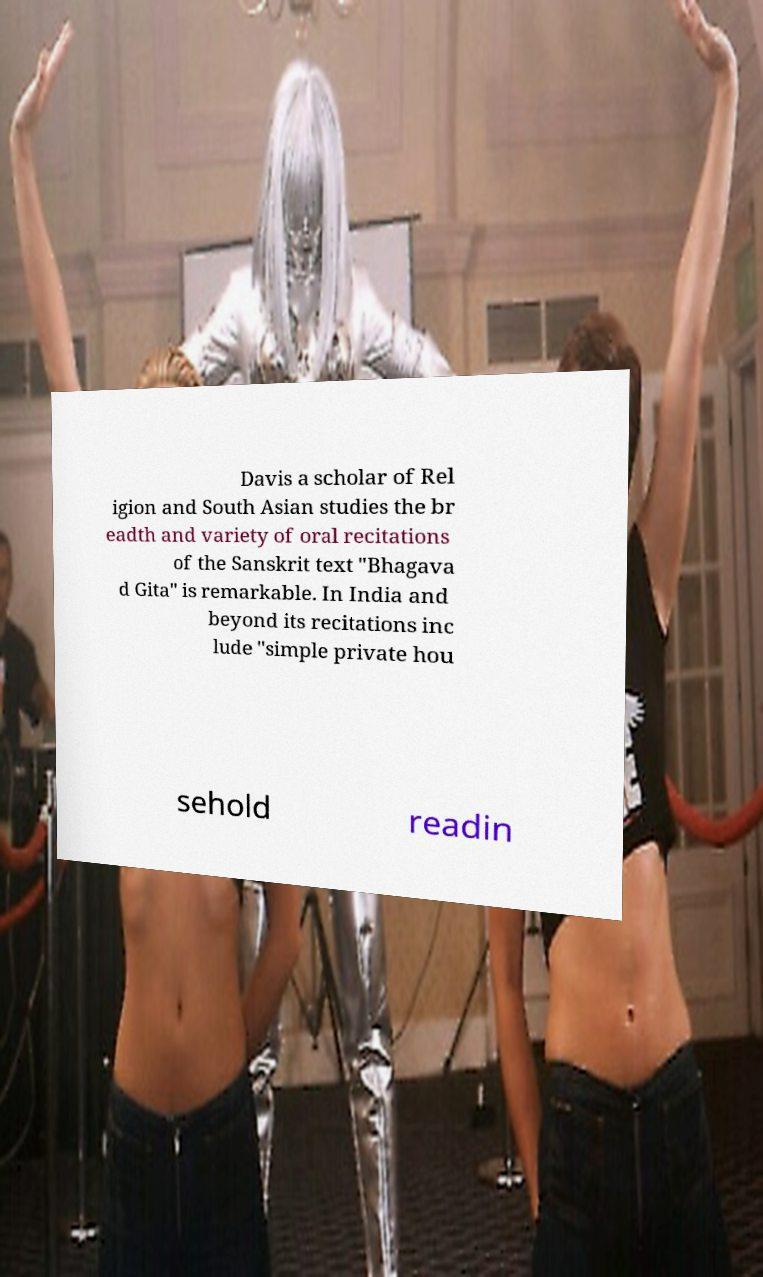What messages or text are displayed in this image? I need them in a readable, typed format. Davis a scholar of Rel igion and South Asian studies the br eadth and variety of oral recitations of the Sanskrit text "Bhagava d Gita" is remarkable. In India and beyond its recitations inc lude "simple private hou sehold readin 